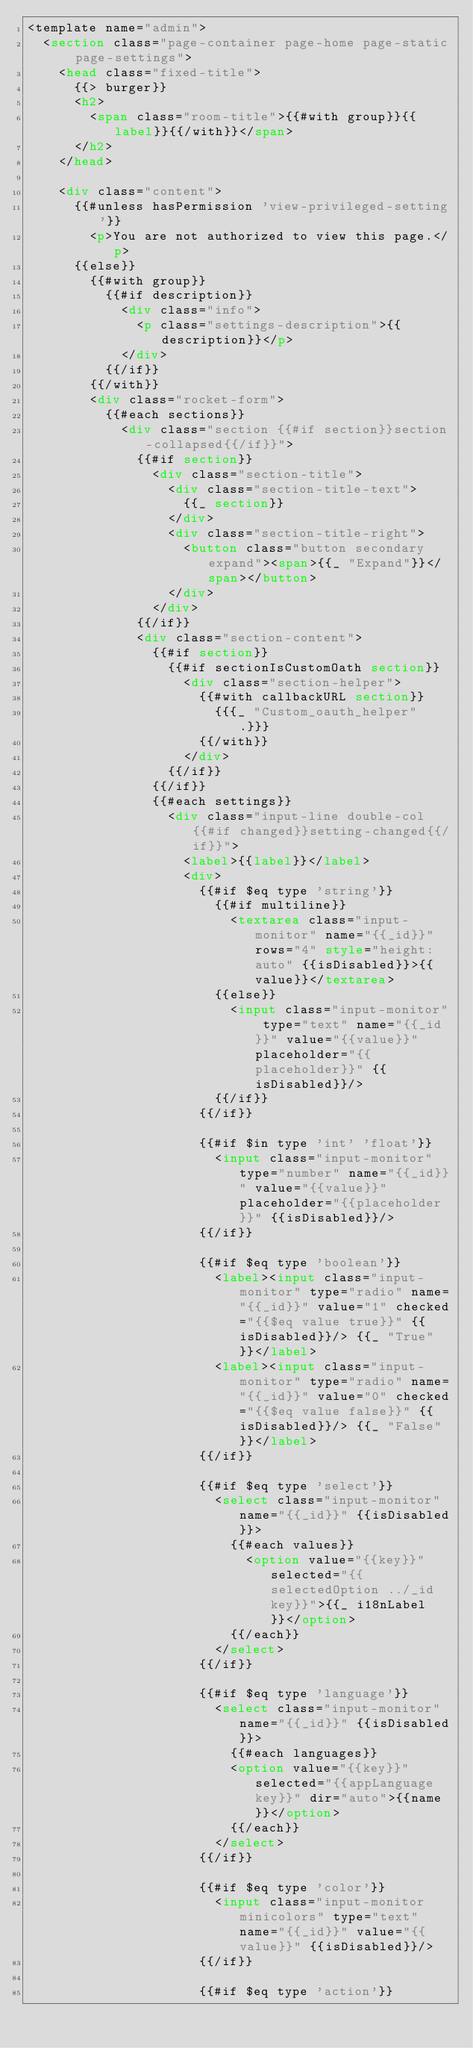<code> <loc_0><loc_0><loc_500><loc_500><_HTML_><template name="admin">
	<section class="page-container page-home page-static page-settings">
		<head class="fixed-title">
			{{> burger}}
			<h2>
				<span class="room-title">{{#with group}}{{label}}{{/with}}</span>
			</h2>
		</head>

		<div class="content">
			{{#unless hasPermission 'view-privileged-setting'}}
				<p>You are not authorized to view this page.</p>
			{{else}}
				{{#with group}}
					{{#if description}}
						<div class="info">
							<p class="settings-description">{{description}}</p>
						</div>
					{{/if}}
				{{/with}}
				<div class="rocket-form">
					{{#each sections}}
						<div class="section {{#if section}}section-collapsed{{/if}}">
							{{#if section}}
								<div class="section-title">
									<div class="section-title-text">
										{{_ section}}
									</div>
									<div class="section-title-right">
										<button class="button secondary expand"><span>{{_ "Expand"}}</span></button>
									</div>
								</div>
							{{/if}}
							<div class="section-content">
								{{#if section}}
									{{#if sectionIsCustomOath section}}
										<div class="section-helper">
											{{#with callbackURL section}}
												{{{_ "Custom_oauth_helper" .}}}
											{{/with}}
										</div>
									{{/if}}
								{{/if}}
								{{#each settings}}
									<div class="input-line double-col {{#if changed}}setting-changed{{/if}}">
										<label>{{label}}</label>
										<div>
											{{#if $eq type 'string'}}
												{{#if multiline}}
													<textarea class="input-monitor" name="{{_id}}" rows="4" style="height: auto" {{isDisabled}}>{{value}}</textarea>
												{{else}}
													<input class="input-monitor" type="text" name="{{_id}}" value="{{value}}" placeholder="{{placeholder}}" {{isDisabled}}/>
												{{/if}}
											{{/if}}

											{{#if $in type 'int' 'float'}}
												<input class="input-monitor" type="number" name="{{_id}}" value="{{value}}" placeholder="{{placeholder}}" {{isDisabled}}/>
											{{/if}}

											{{#if $eq type 'boolean'}}
												<label><input class="input-monitor" type="radio" name="{{_id}}" value="1" checked="{{$eq value true}}" {{isDisabled}}/> {{_ "True"}}</label>
												<label><input class="input-monitor" type="radio" name="{{_id}}" value="0" checked="{{$eq value false}}" {{isDisabled}}/> {{_ "False"}}</label>
											{{/if}}

											{{#if $eq type 'select'}}
												<select class="input-monitor" name="{{_id}}" {{isDisabled}}>
													{{#each values}}
														<option value="{{key}}" selected="{{selectedOption ../_id key}}">{{_ i18nLabel}}</option>
													{{/each}}
												</select>
											{{/if}}

											{{#if $eq type 'language'}}
												<select class="input-monitor" name="{{_id}}" {{isDisabled}}>
													{{#each languages}}
													<option value="{{key}}" selected="{{appLanguage key}}" dir="auto">{{name}}</option>
													{{/each}}
												</select>
											{{/if}}

											{{#if $eq type 'color'}}
												<input class="input-monitor minicolors" type="text" name="{{_id}}" value="{{value}}" {{isDisabled}}/>
											{{/if}}

											{{#if $eq type 'action'}}</code> 